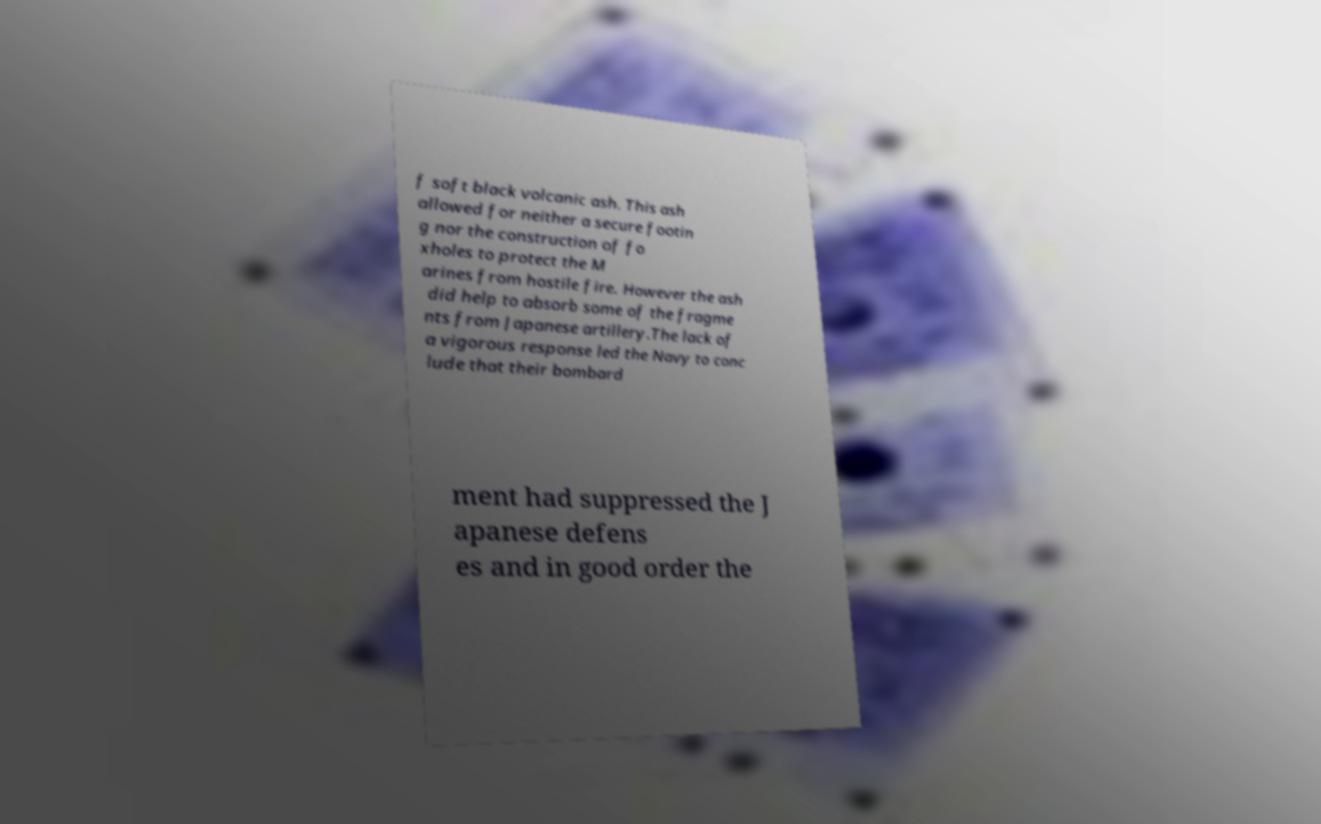Could you extract and type out the text from this image? f soft black volcanic ash. This ash allowed for neither a secure footin g nor the construction of fo xholes to protect the M arines from hostile fire. However the ash did help to absorb some of the fragme nts from Japanese artillery.The lack of a vigorous response led the Navy to conc lude that their bombard ment had suppressed the J apanese defens es and in good order the 